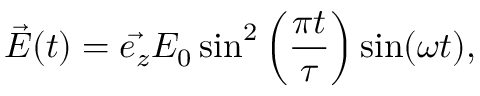<formula> <loc_0><loc_0><loc_500><loc_500>\vec { E } ( t ) = \vec { e _ { z } } E _ { 0 } \sin ^ { 2 } \left ( \frac { \pi t } { \tau } \right ) \sin ( \omega t ) ,</formula> 